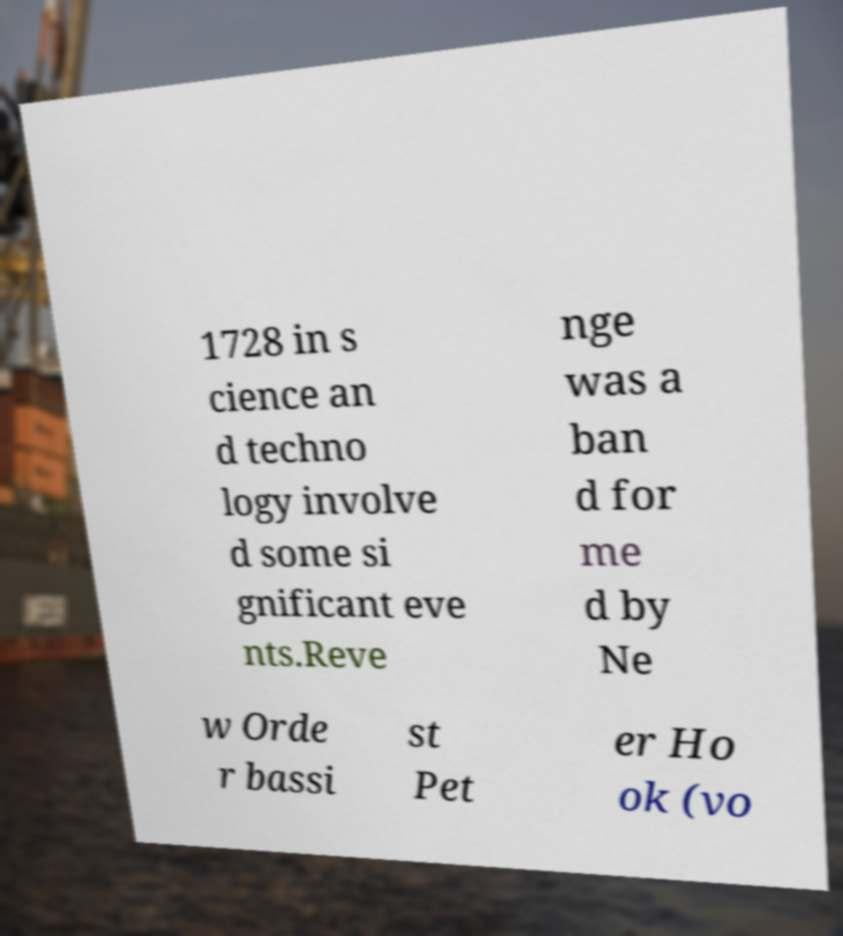Can you read and provide the text displayed in the image?This photo seems to have some interesting text. Can you extract and type it out for me? 1728 in s cience an d techno logy involve d some si gnificant eve nts.Reve nge was a ban d for me d by Ne w Orde r bassi st Pet er Ho ok (vo 